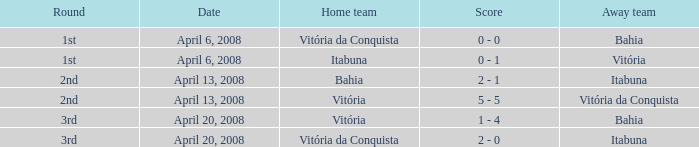What is the moniker for the home side in a 2nd round match featuring vitória da conquista as the away team? Vitória. 